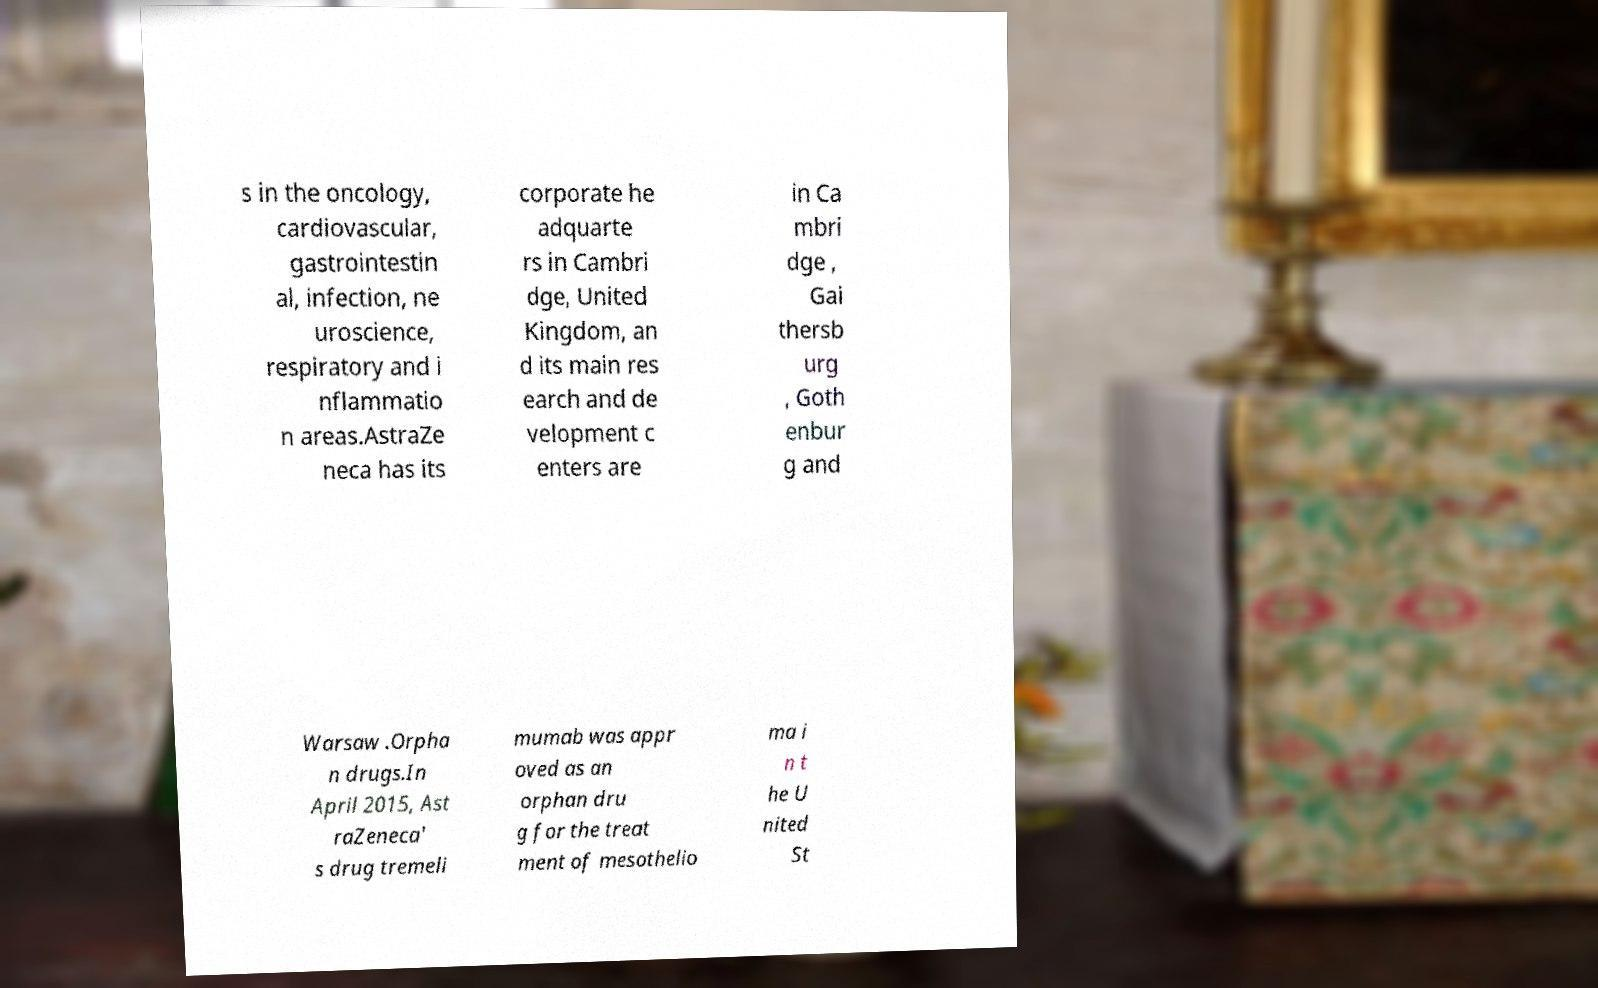What messages or text are displayed in this image? I need them in a readable, typed format. s in the oncology, cardiovascular, gastrointestin al, infection, ne uroscience, respiratory and i nflammatio n areas.AstraZe neca has its corporate he adquarte rs in Cambri dge, United Kingdom, an d its main res earch and de velopment c enters are in Ca mbri dge , Gai thersb urg , Goth enbur g and Warsaw .Orpha n drugs.In April 2015, Ast raZeneca' s drug tremeli mumab was appr oved as an orphan dru g for the treat ment of mesothelio ma i n t he U nited St 